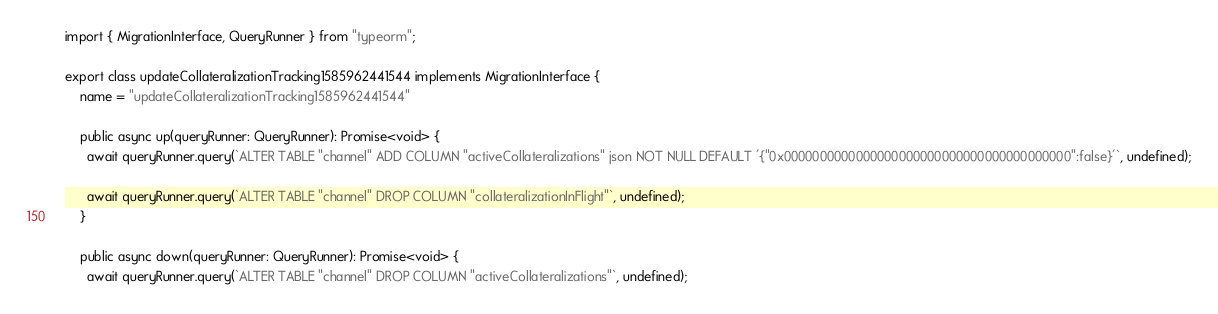Convert code to text. <code><loc_0><loc_0><loc_500><loc_500><_TypeScript_>import { MigrationInterface, QueryRunner } from "typeorm";

export class updateCollateralizationTracking1585962441544 implements MigrationInterface {
    name = "updateCollateralizationTracking1585962441544"

    public async up(queryRunner: QueryRunner): Promise<void> {
      await queryRunner.query(`ALTER TABLE "channel" ADD COLUMN "activeCollateralizations" json NOT NULL DEFAULT '{"0x0000000000000000000000000000000000000000":false}'`, undefined);

      await queryRunner.query(`ALTER TABLE "channel" DROP COLUMN "collateralizationInFlight"`, undefined);
    }

    public async down(queryRunner: QueryRunner): Promise<void> {
      await queryRunner.query(`ALTER TABLE "channel" DROP COLUMN "activeCollateralizations"`, undefined);
</code> 